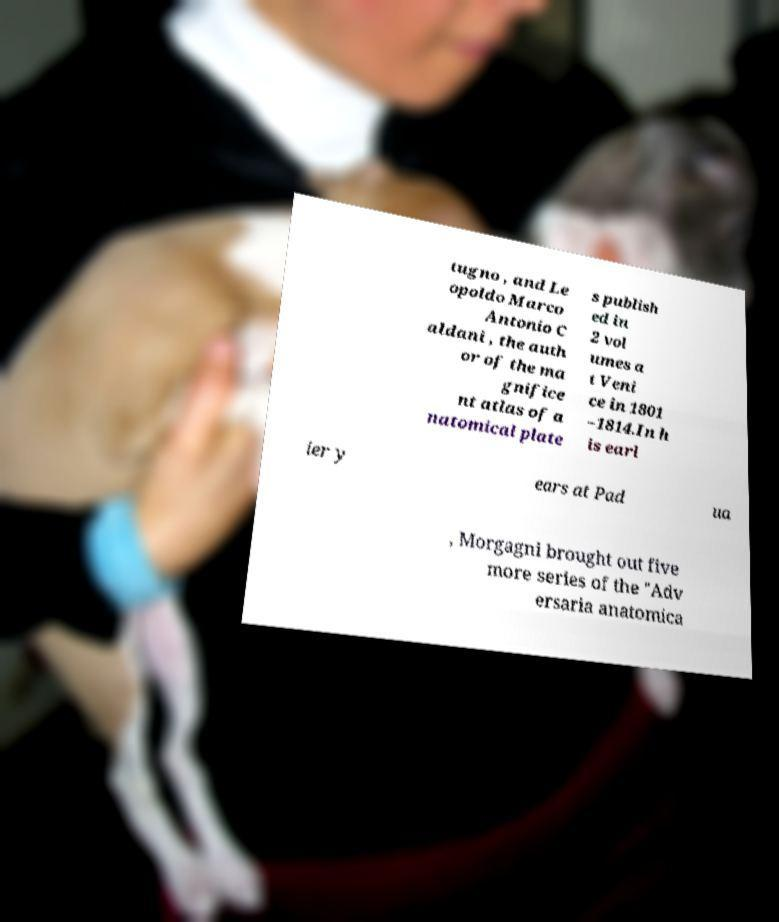Can you accurately transcribe the text from the provided image for me? tugno , and Le opoldo Marco Antonio C aldani , the auth or of the ma gnifice nt atlas of a natomical plate s publish ed in 2 vol umes a t Veni ce in 1801 –1814.In h is earl ier y ears at Pad ua , Morgagni brought out five more series of the "Adv ersaria anatomica 